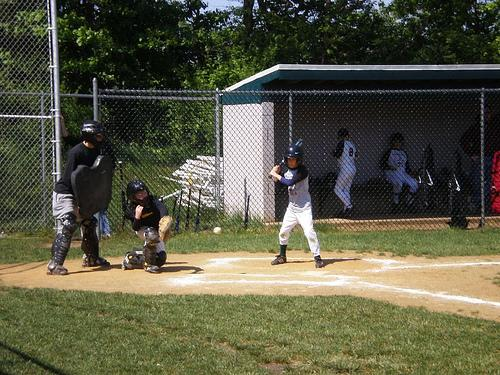Where do those who await their turn at bat wait? Please explain your reasoning. behind fence. Other players are sitting at bench. there's a protective fence to keep from getting hit. 